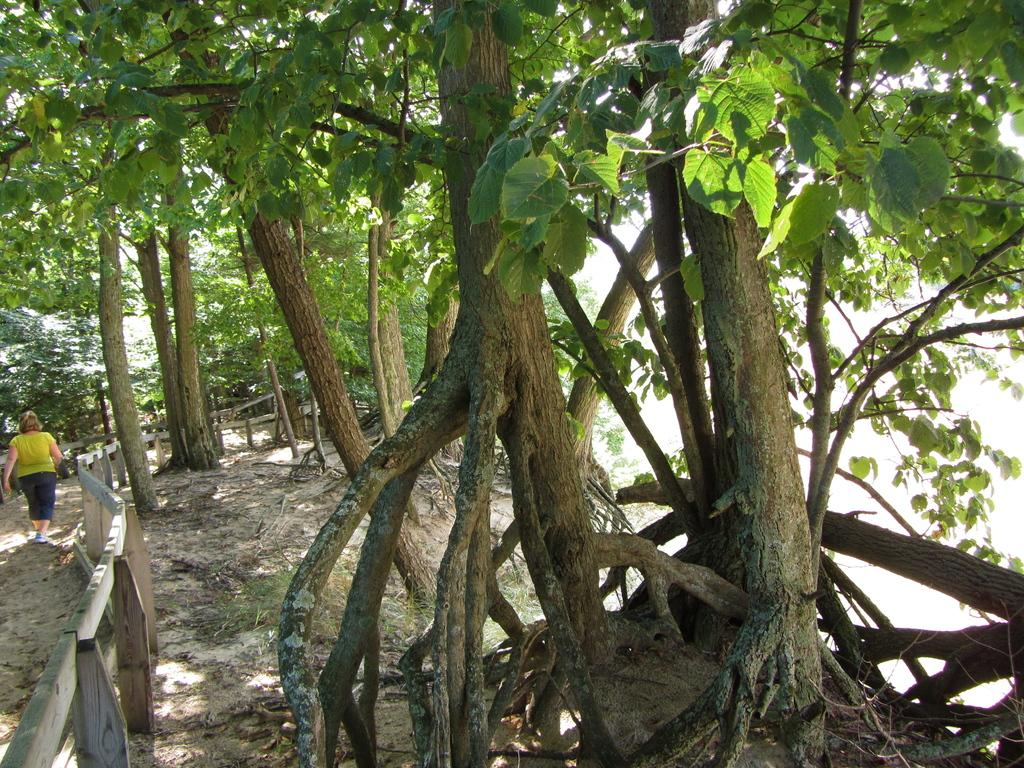What type of vegetation can be seen in the image? There are trees in the image. What kind of barrier is present in the image? There is a wooden fence in the image. Can you describe the activity of the person in the image? A woman is walking in the image. What is the name of the woman's daughter who is waving good-bye in the image? There is no daughter or good-bye gesture present in the image. How many toes can be seen on the woman's foot in the image? The image does not show the woman's foot or any toes. 